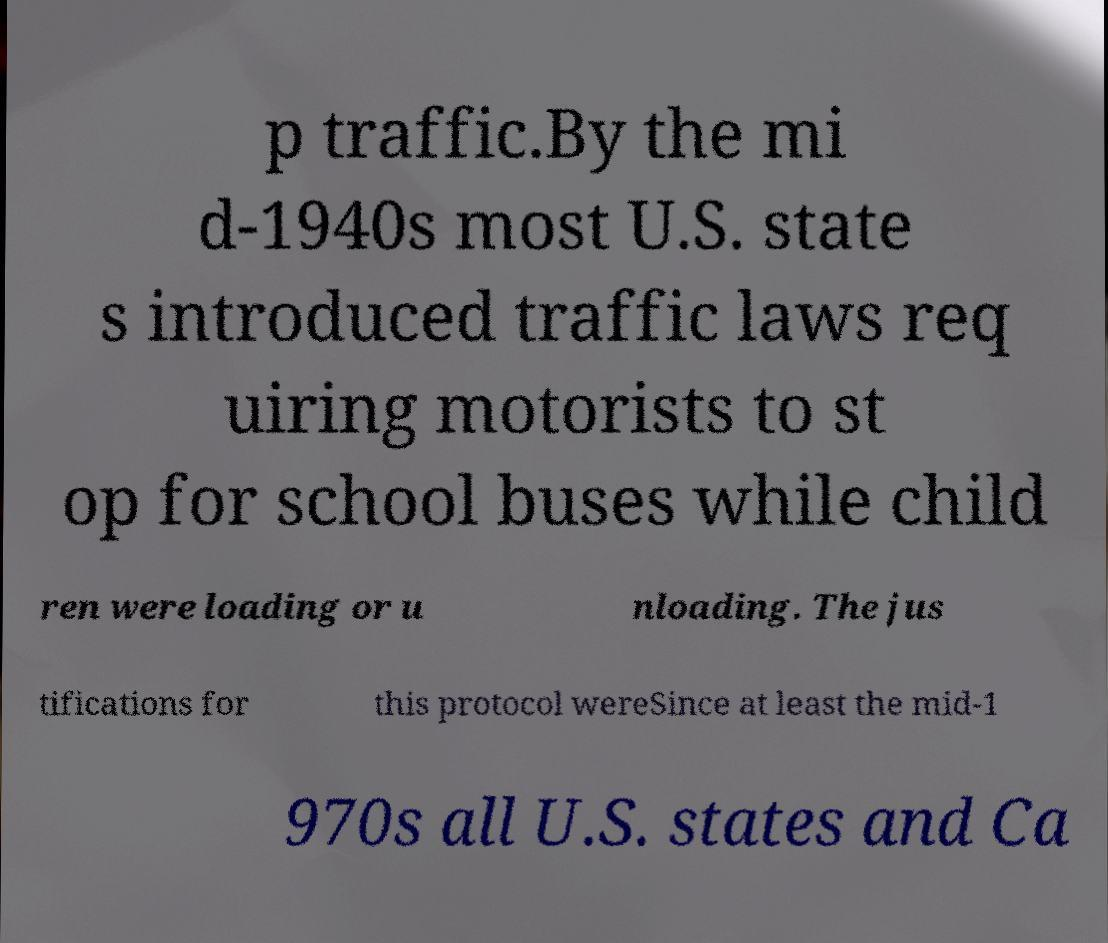Could you extract and type out the text from this image? p traffic.By the mi d-1940s most U.S. state s introduced traffic laws req uiring motorists to st op for school buses while child ren were loading or u nloading. The jus tifications for this protocol wereSince at least the mid-1 970s all U.S. states and Ca 